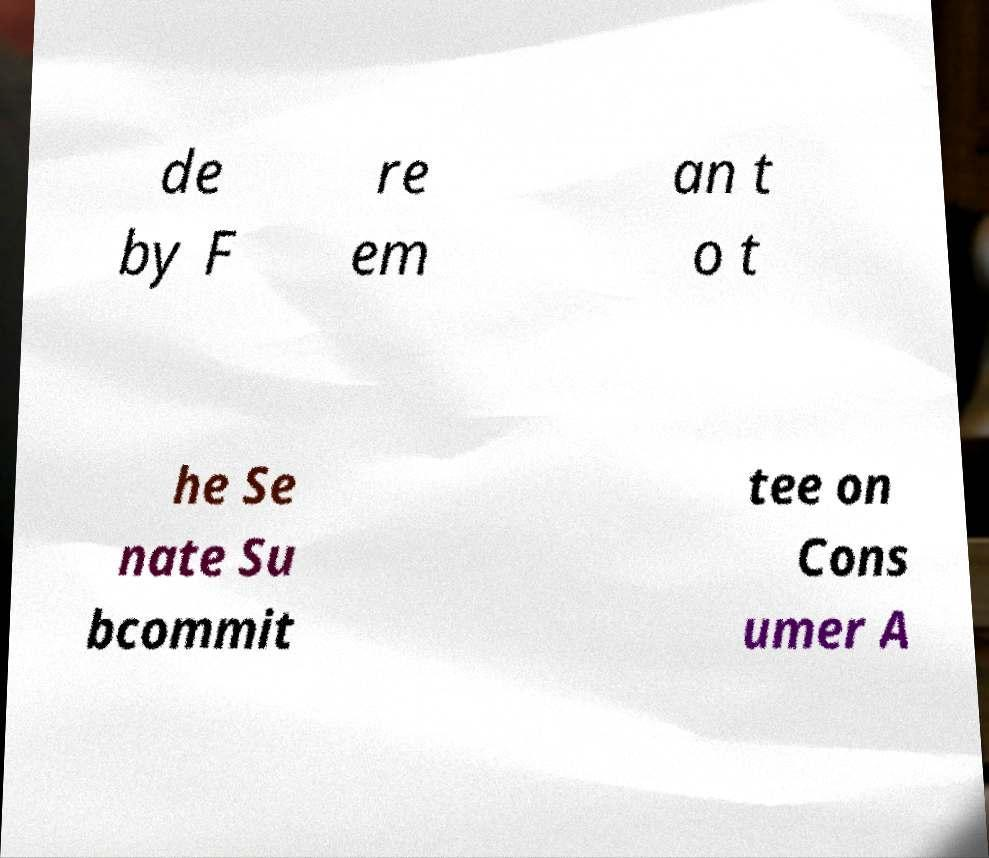Could you extract and type out the text from this image? de by F re em an t o t he Se nate Su bcommit tee on Cons umer A 